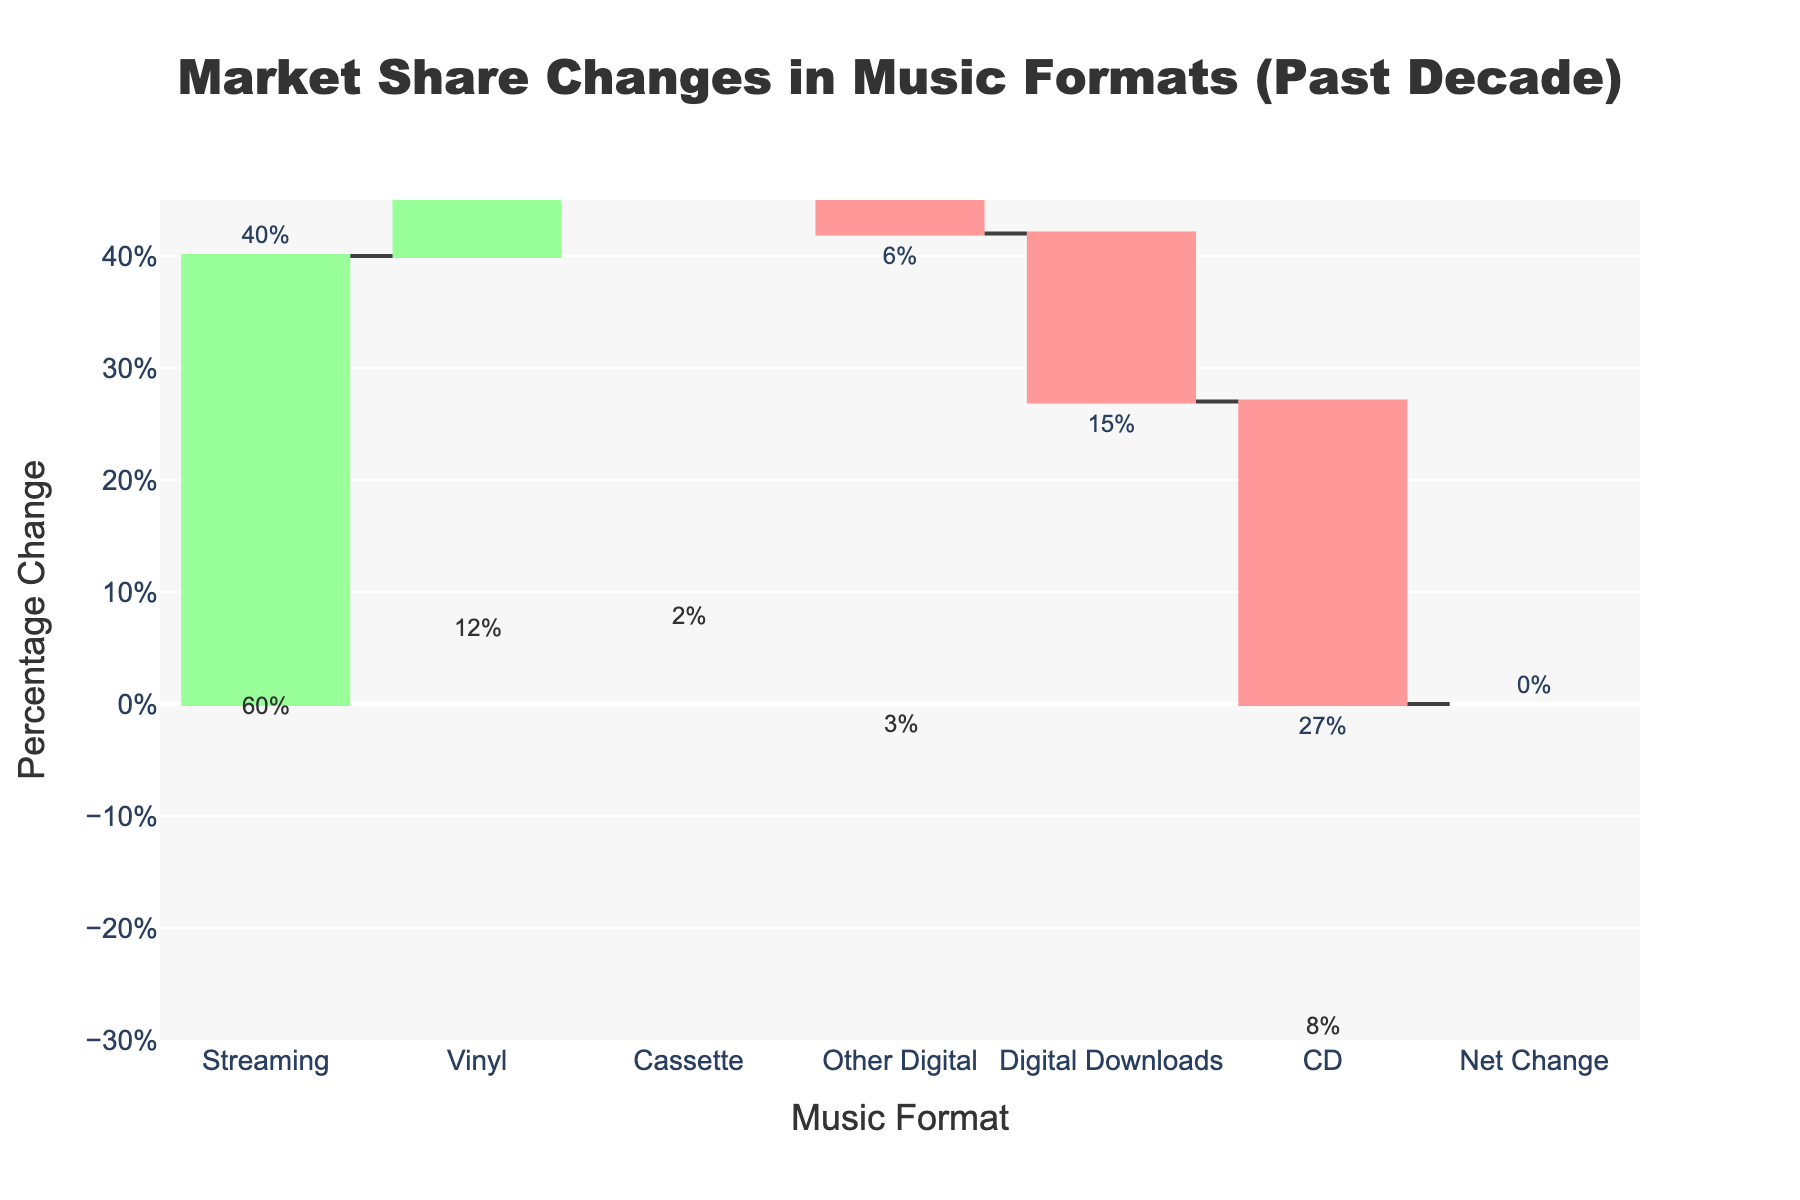What is the title of the figure? The title of the figure is prominently displayed at the top and states "Market Share Changes in Music Formats (Past Decade)."
Answer: Market Share Changes in Music Formats (Past Decade) Which music format experienced the greatest increase in market share? The green bar representing the increase is the tallest for the format labeled "Streaming." This indicates Streaming experienced the greatest increase in market share.
Answer: Streaming How much did the market share for CDs change over the past decade? The red bar representing CDs has an accompanying text label showing "-27%."
Answer: -27% By how much did the combined market share of Digital Downloads and Other Digital formats decrease? Summing the changes for Digital Downloads (-15%) and Other Digital (-6%), we get a total decrease of -21%.
Answer: -21% What is the net change in market share for all formats combined over the past decade? The figure includes a bar labeled "Net Change" which shows the sum of all individual changes. The label for this bar shows "0%" indicating no net change.
Answer: 0% What are the final market shares for Streaming and Vinyl, and which is higher? The annotations above the Streaming and Vinyl bars show their final market shares as "60%" and "12%" respectively. Streaming, therefore, has a higher final market share.
Answer: Streaming Which format had the smallest positive change in market share? Among the green bars indicating positive changes, Cassette has the smallest bar with an accompanying "+1%" label.
Answer: Cassette What percentage increase does the Vinyl format show? The green bar for Vinyl has an accompanying "+7%" label indicating a 7% increase in market share.
Answer: 7% Are there any formats that had an identical start and end market share? The CD format shows a decrease from 35% to 8%, and all other formats also show different starting and ending shares. Hence, no formats have identical start and end shares.
Answer: No 